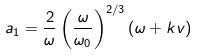Convert formula to latex. <formula><loc_0><loc_0><loc_500><loc_500>a _ { 1 } = \frac { 2 } { \omega } \left ( \frac { \omega } { \omega _ { 0 } } \right ) ^ { 2 / 3 } \left ( \omega + k v \right )</formula> 